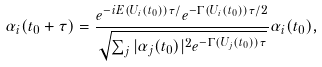<formula> <loc_0><loc_0><loc_500><loc_500>\alpha _ { i } ( t _ { 0 } + \tau ) = \frac { e ^ { - i E ( U _ { i } ( t _ { 0 } ) ) \tau / } e ^ { - \Gamma ( U _ { i } ( t _ { 0 } ) ) \tau / 2 } } { \sqrt { \sum _ { j } | \alpha _ { j } ( t _ { 0 } ) | ^ { 2 } e ^ { - \Gamma ( U _ { j } ( t _ { 0 } ) ) \tau } } } \alpha _ { i } ( t _ { 0 } ) ,</formula> 